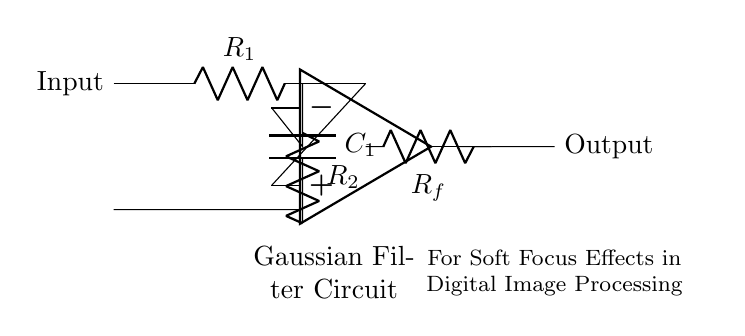What type of filter does this circuit represent? The circuit diagram clearly specifies that it is a Gaussian filter, indicated by the label within the circuit. Gaussian filters are designed to smooth signals or images by averaging nearby values.
Answer: Gaussian filter What components are used in this circuit? The circuit includes a resistor (R1), a capacitor (C1), another resistor (R2), a feedback resistor (Rf), and an operational amplifier (op amp). Each component plays a role in conditioning the input signal.
Answer: Resistor, capacitor, op amp What is the main function of the op amp in this circuit? The operational amplifier amplifies the signal while also providing feedback to control the gain and shape of the filter response. It is crucial for implementing the Gaussian smoothing effect.
Answer: Amplify Which component provides feedback in this circuit? The feedback in the Gaussian filter circuit is provided by the resistor labeled Rf, which connects the output of the op amp back to its inverting input, thereby controlling the filter's response characteristics.
Answer: Rf How many resistors are present in this circuit? There are three resistors specified in the diagram: R1, R2, and Rf. Each resistor contributes differently to the characteristics of the filter and its response to input signals.
Answer: Three What is the purpose of capacitor C1 in the circuit? The capacitor C1 works in conjunction with the resistors to define the time constant for the filter, thereby determining how rapidly the circuit responds to changes in the input signal. This behavior is essential for achieving the desired soft focus effect.
Answer: Time constant 